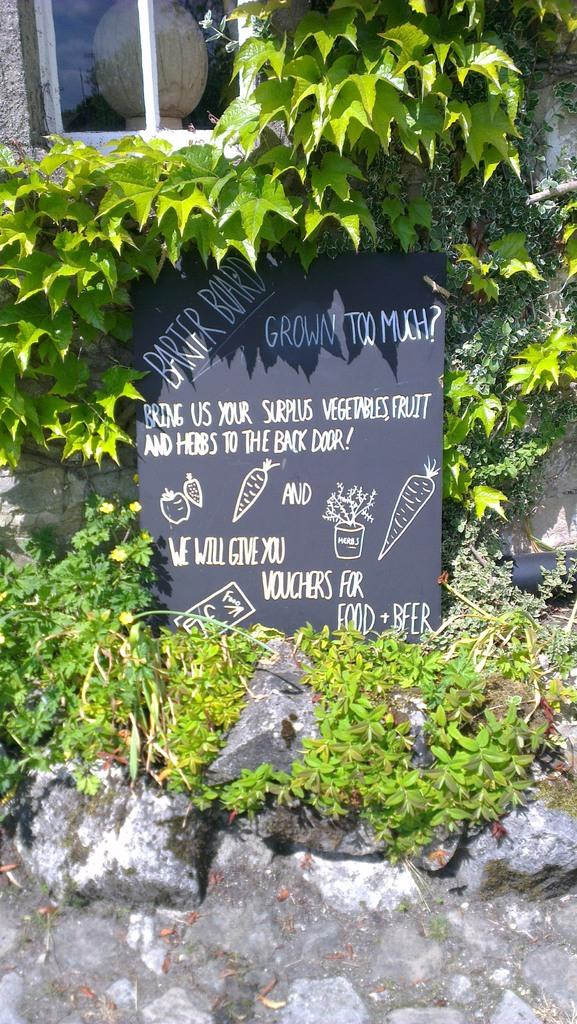What is the main object in the image? There is a black color board in the image. What is written or drawn on the board? There is text on the board. What other objects can be seen in the image? There are stones and plants in the image. What can be seen in the background of the image? There is a window visible in the background of the image. How many tomatoes are being offered in the wilderness in the image? There are no tomatoes or wilderness present in the image. 